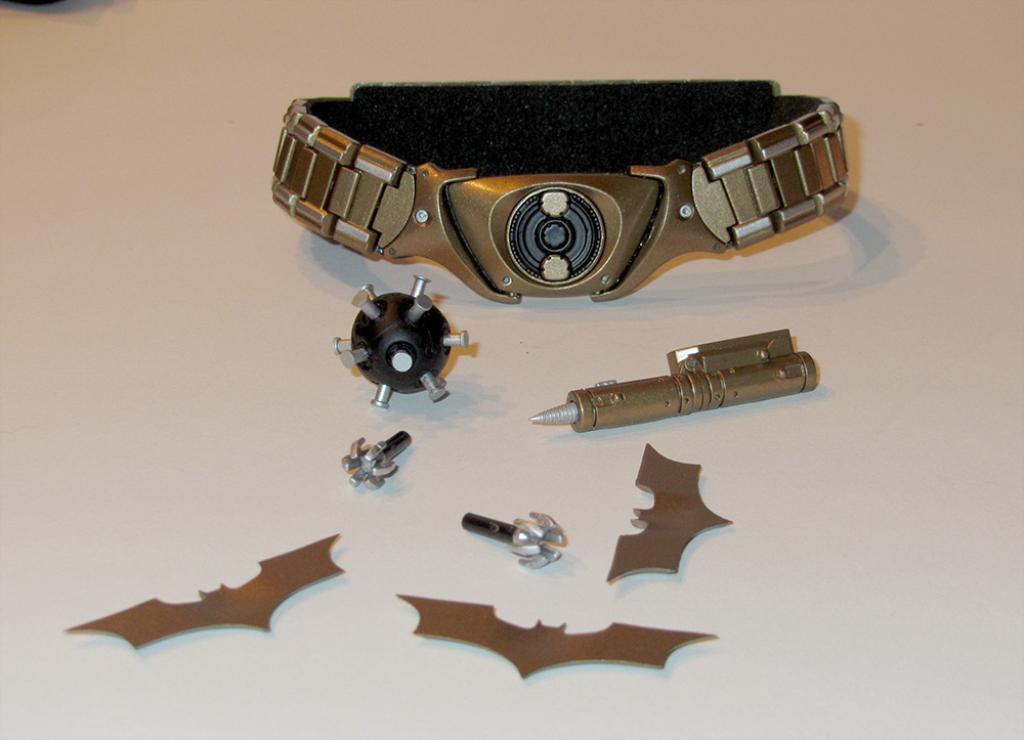Could you give a brief overview of what you see in this image? In the image we can see there is a hand bracelet, ball, iron pen and other items kept on the table. 